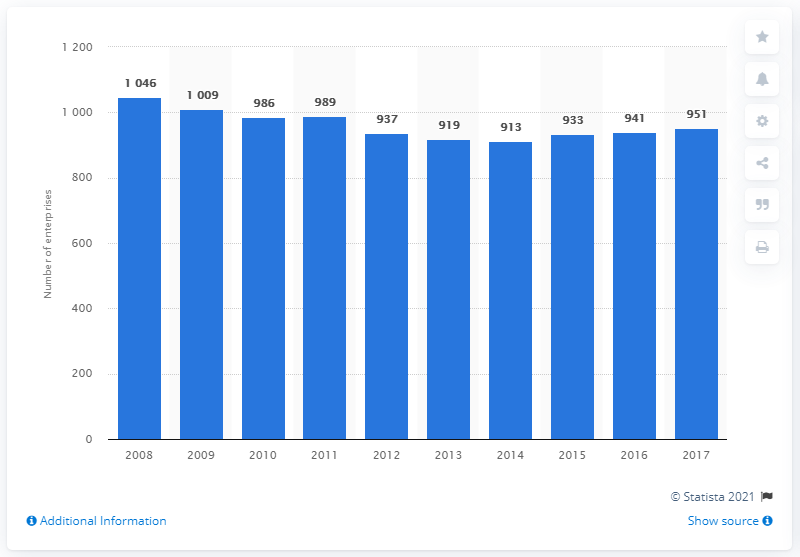List a handful of essential elements in this visual. In 2017, there were 951 companies in Portugal that manufactured plastic products. 